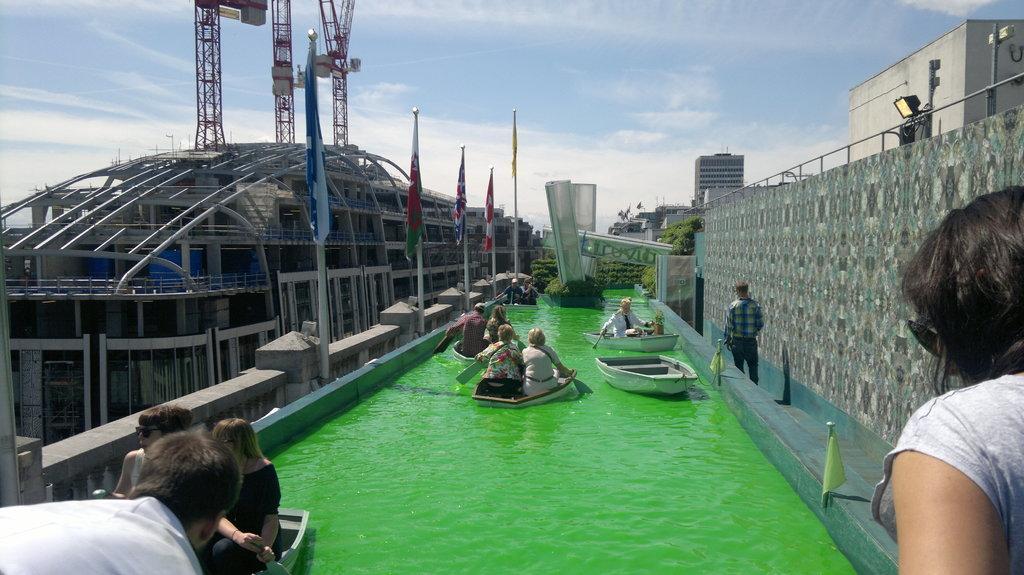How would you summarize this image in a sentence or two? In the image we can see there are many people around. We can see there are even boats in the water and the water is green in color. We can even see the flags, wall and construction. We can even see there are towers and the cloudy sky. 